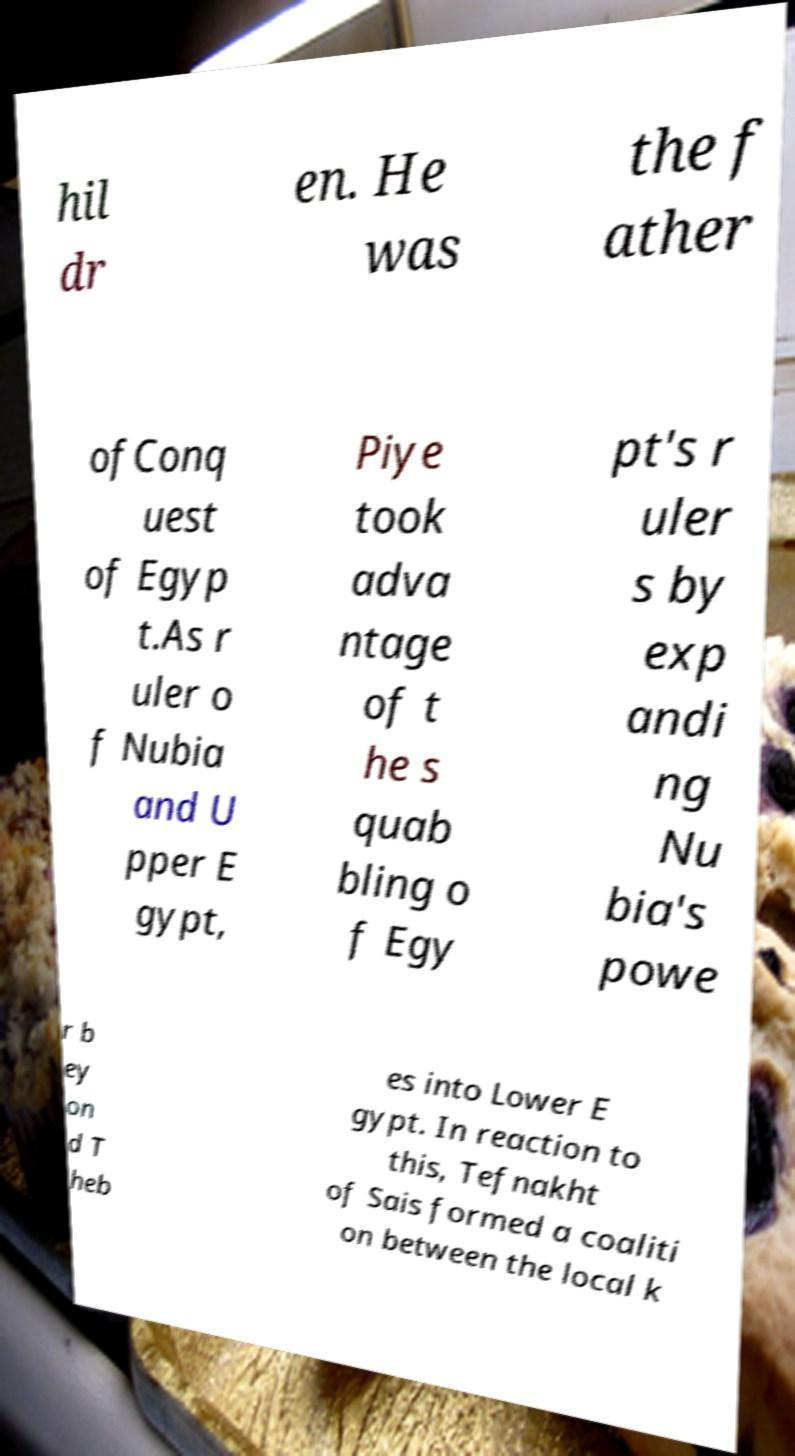Can you read and provide the text displayed in the image?This photo seems to have some interesting text. Can you extract and type it out for me? hil dr en. He was the f ather ofConq uest of Egyp t.As r uler o f Nubia and U pper E gypt, Piye took adva ntage of t he s quab bling o f Egy pt's r uler s by exp andi ng Nu bia's powe r b ey on d T heb es into Lower E gypt. In reaction to this, Tefnakht of Sais formed a coaliti on between the local k 